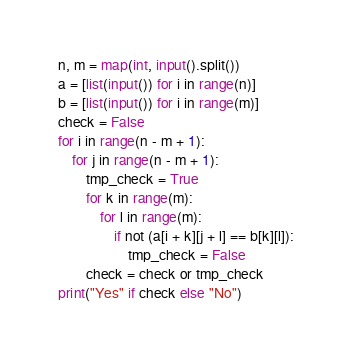<code> <loc_0><loc_0><loc_500><loc_500><_Python_>n, m = map(int, input().split())
a = [list(input()) for i in range(n)]
b = [list(input()) for i in range(m)]
check = False
for i in range(n - m + 1):
    for j in range(n - m + 1):
        tmp_check = True
        for k in range(m):
            for l in range(m):
                if not (a[i + k][j + l] == b[k][l]):
                    tmp_check = False
        check = check or tmp_check
print("Yes" if check else "No")</code> 